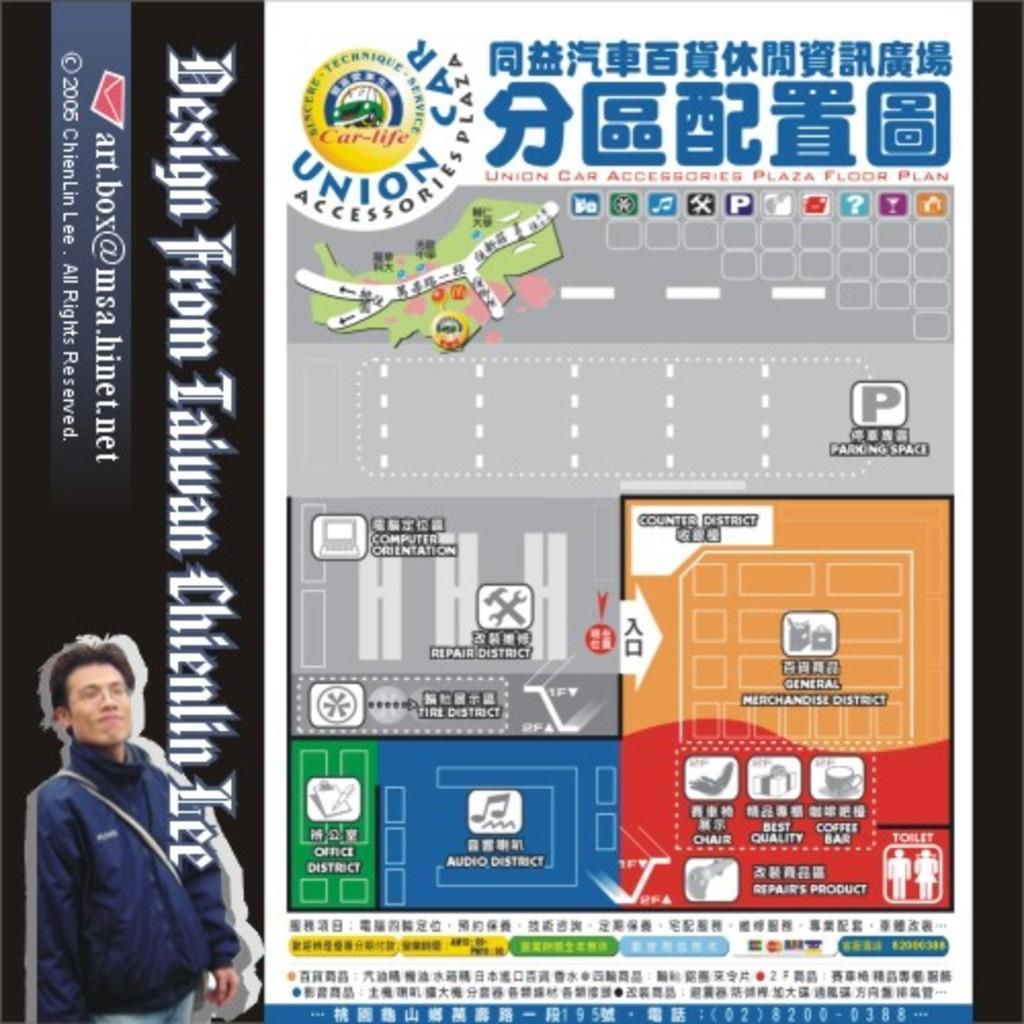Provide a one-sentence caption for the provided image. A map of a Union Car Accessories plaza showing where different rooms are located. 